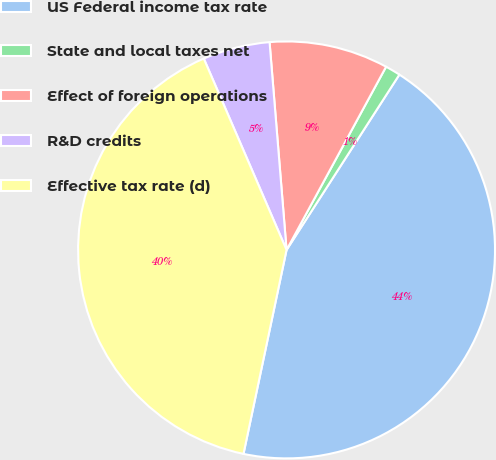Convert chart to OTSL. <chart><loc_0><loc_0><loc_500><loc_500><pie_chart><fcel>US Federal income tax rate<fcel>State and local taxes net<fcel>Effect of foreign operations<fcel>R&D credits<fcel>Effective tax rate (d)<nl><fcel>44.21%<fcel>1.18%<fcel>9.22%<fcel>5.2%<fcel>40.19%<nl></chart> 